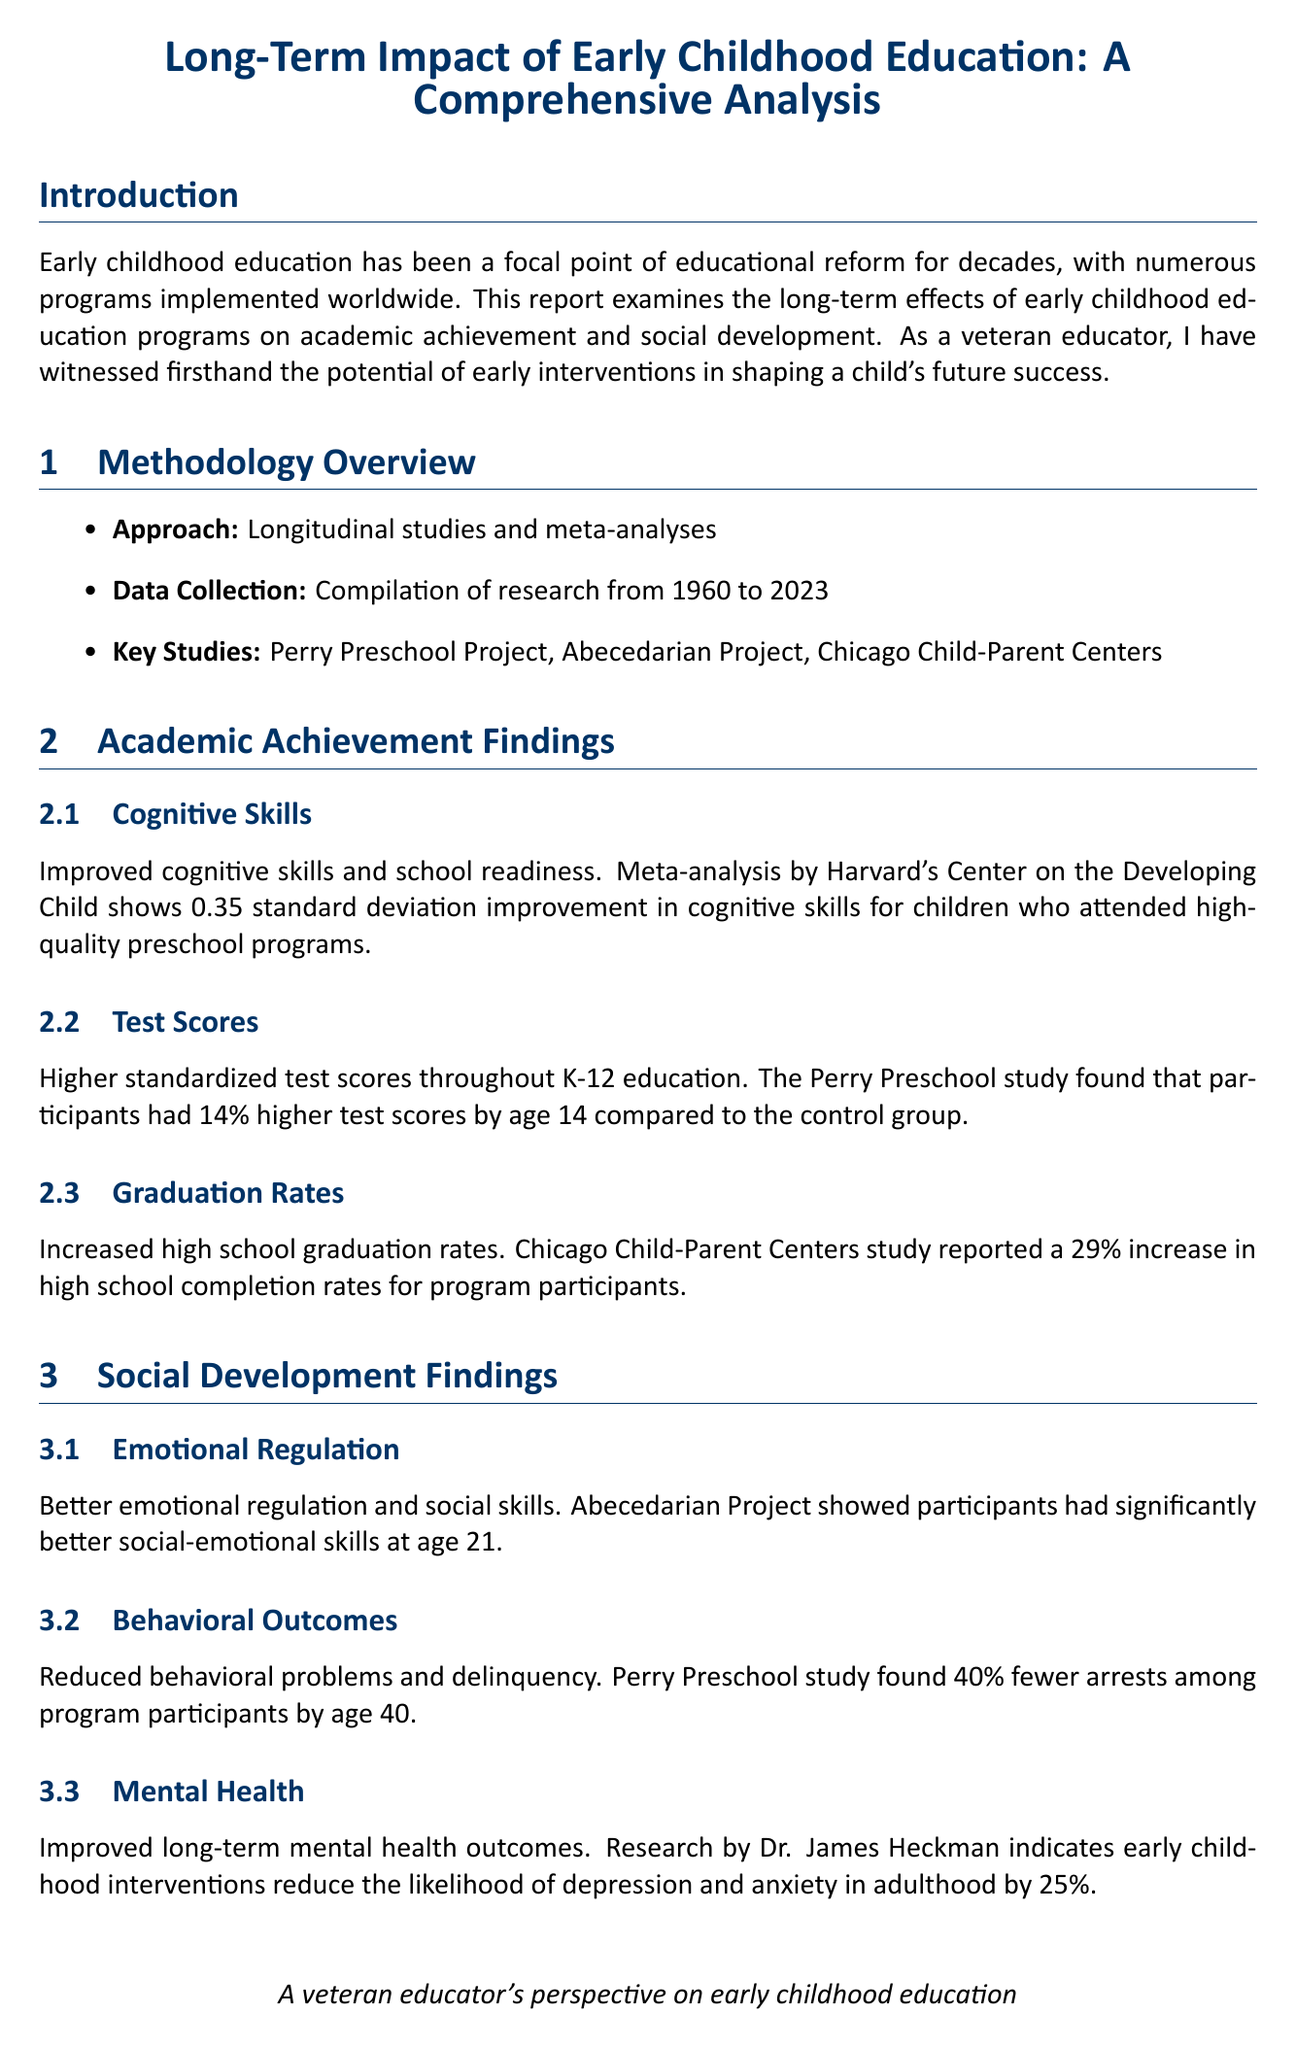what is the report title? The report title is explicitly mentioned in the document's header.
Answer: Long-Term Impact of Early Childhood Education: A Comprehensive Analysis what years does the data collection cover? The data collection period is stated in the methodology overview section.
Answer: 1960 to 2023 which project showed a 29% increase in high school completion rates? This information is found in the academic achievement findings under graduation rates.
Answer: Chicago Child-Parent Centers what percentage of higher average earnings did Abecedarian Project participants have at age 30? This statistic is stated under employment outcomes in the economic impact section.
Answer: 42% who is affiliated with the Harvard Center on the Developing Child? The document cites several expert opinions with affiliations to the authors.
Answer: Dr. Jack P. Shonkoff what is a challenge mentioned regarding early childhood education programs? Several challenges are listed in the challenges and limitations section of the report.
Answer: Inconsistent quality across different early childhood programs what is the recommended public investment focus? This recommendation is presented in the recommendations section and highlights a key action.
Answer: High-quality early childhood education programs how much annual return on investment does James Heckman calculate for high-quality programs? This is derived from the cost-benefit analysis section under economic impact.
Answer: 13% 